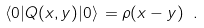<formula> <loc_0><loc_0><loc_500><loc_500>\langle 0 | Q ( x , y ) | 0 \rangle \, = \rho ( x - y ) \ .</formula> 